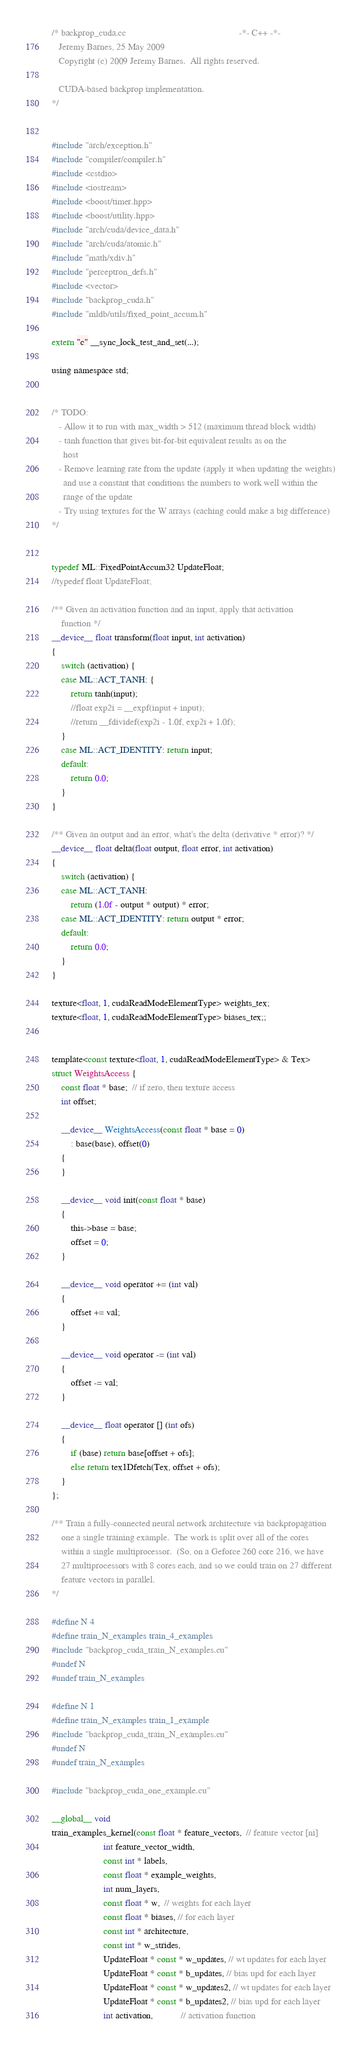Convert code to text. <code><loc_0><loc_0><loc_500><loc_500><_Cuda_>/* backprop_cuda.cc                                                -*- C++ -*-
   Jeremy Barnes, 25 May 2009
   Copyright (c) 2009 Jeremy Barnes.  All rights reserved.

   CUDA-based backprop implementation.
*/


#include "arch/exception.h"
#include "compiler/compiler.h"
#include <cstdio>
#include <iostream>
#include <boost/timer.hpp>
#include <boost/utility.hpp>
#include "arch/cuda/device_data.h"
#include "arch/cuda/atomic.h"
#include "math/xdiv.h"
#include "perceptron_defs.h"
#include <vector>
#include "backprop_cuda.h"
#include "mldb/utils/fixed_point_accum.h"

extern "c" __sync_lock_test_and_set(...);

using namespace std;


/* TODO:
   - Allow it to run with max_width > 512 (maximum thread block width)
   - tanh function that gives bit-for-bit equivalent results as on the
     host
   - Remove learning rate from the update (apply it when updating the weights)
     and use a constant that conditions the numbers to work well within the
     range of the update
   - Try using textures for the W arrays (caching could make a big difference)
*/


typedef ML::FixedPointAccum32 UpdateFloat;
//typedef float UpdateFloat;

/** Given an activation function and an input, apply that activation
    function */
__device__ float transform(float input, int activation)
{
    switch (activation) {
    case ML::ACT_TANH: {
        return tanh(input);
        //float exp2i = __expf(input + input);
        //return __fdividef(exp2i - 1.0f, exp2i + 1.0f);
    }
    case ML::ACT_IDENTITY: return input;
    default:
        return 0.0;
    }
}

/** Given an output and an error, what's the delta (derivative * error)? */
__device__ float delta(float output, float error, int activation)
{
    switch (activation) {
    case ML::ACT_TANH:
        return (1.0f - output * output) * error;
    case ML::ACT_IDENTITY: return output * error; 
    default:
        return 0.0;
    }
}

texture<float, 1, cudaReadModeElementType> weights_tex;
texture<float, 1, cudaReadModeElementType> biases_tex;;


template<const texture<float, 1, cudaReadModeElementType> & Tex>
struct WeightsAccess {
    const float * base;  // if zero, then texture access
    int offset;

    __device__ WeightsAccess(const float * base = 0)
        : base(base), offset(0)
    {
    }

    __device__ void init(const float * base)
    {
        this->base = base;
        offset = 0;
    }

    __device__ void operator += (int val)
    {
        offset += val;
    }

    __device__ void operator -= (int val)
    {
        offset -= val;
    }

    __device__ float operator [] (int ofs)
    {
        if (base) return base[offset + ofs];
        else return tex1Dfetch(Tex, offset + ofs);
    }
};

/** Train a fully-connected neural network architecture via backpropagation
    one a single training example.  The work is split over all of the cores
    within a single multiprocessor.  (So, on a Geforce 260 core 216, we have
    27 multiprocessors with 8 cores each, and so we could train on 27 different
    feature vectors in parallel.
*/

#define N 4
#define train_N_examples train_4_examples
#include "backprop_cuda_train_N_examples.cu"
#undef N
#undef train_N_examples

#define N 1
#define train_N_examples train_1_example
#include "backprop_cuda_train_N_examples.cu"
#undef N
#undef train_N_examples

#include "backprop_cuda_one_example.cu"

__global__ void
train_examples_kernel(const float * feature_vectors,  // feature vector [ni]
                      int feature_vector_width,
                      const int * labels,
                      const float * example_weights,
                      int num_layers,
                      const float * w,  // weights for each layer
                      const float * biases, // for each layer
                      const int * architecture,
                      const int * w_strides,
                      UpdateFloat * const * w_updates, // wt updates for each layer
                      UpdateFloat * const * b_updates, // bias upd for each layer
                      UpdateFloat * const * w_updates2, // wt updates for each layer
                      UpdateFloat * const * b_updates2, // bias upd for each layer
                      int activation,            // activation function</code> 